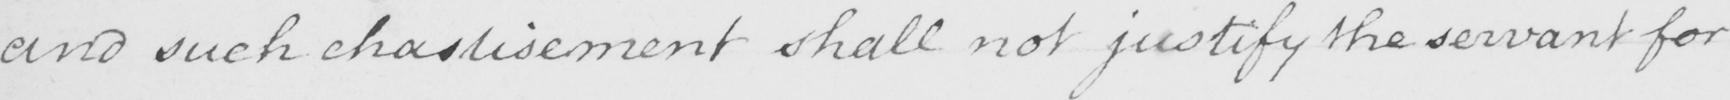Please provide the text content of this handwritten line. and such chastisement shall not justify the servant for 